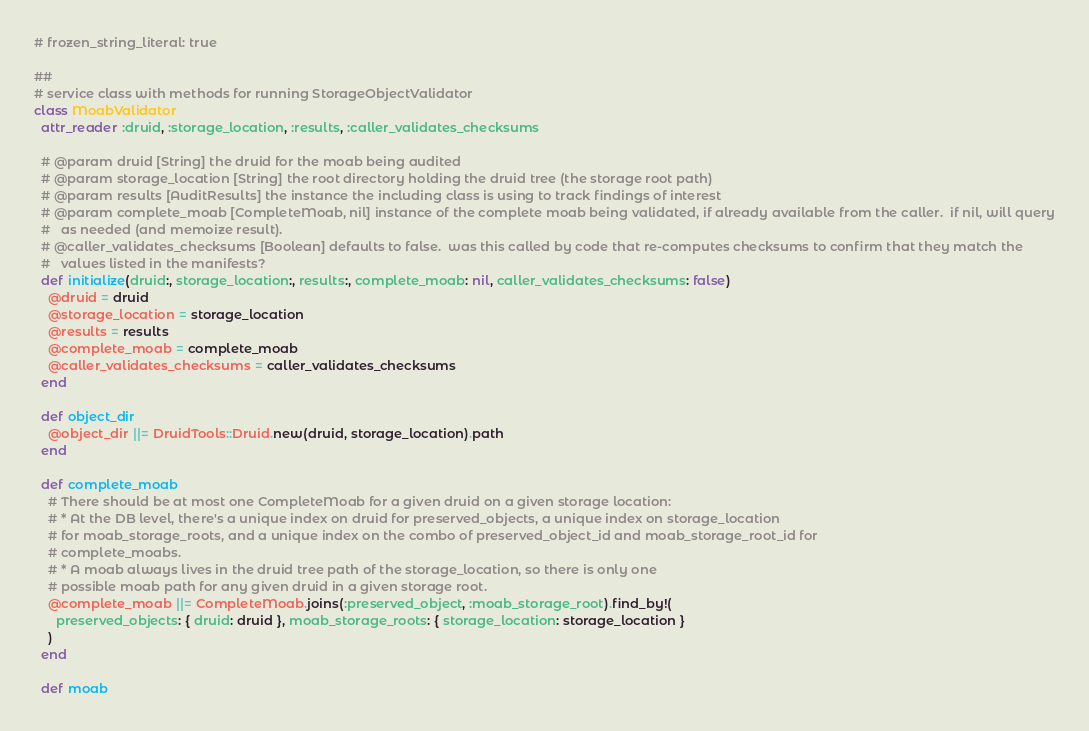<code> <loc_0><loc_0><loc_500><loc_500><_Ruby_># frozen_string_literal: true

##
# service class with methods for running StorageObjectValidator
class MoabValidator
  attr_reader :druid, :storage_location, :results, :caller_validates_checksums

  # @param druid [String] the druid for the moab being audited
  # @param storage_location [String] the root directory holding the druid tree (the storage root path)
  # @param results [AuditResults] the instance the including class is using to track findings of interest
  # @param complete_moab [CompleteMoab, nil] instance of the complete moab being validated, if already available from the caller.  if nil, will query
  #   as needed (and memoize result).
  # @caller_validates_checksums [Boolean] defaults to false.  was this called by code that re-computes checksums to confirm that they match the
  #   values listed in the manifests?
  def initialize(druid:, storage_location:, results:, complete_moab: nil, caller_validates_checksums: false)
    @druid = druid
    @storage_location = storage_location
    @results = results
    @complete_moab = complete_moab
    @caller_validates_checksums = caller_validates_checksums
  end

  def object_dir
    @object_dir ||= DruidTools::Druid.new(druid, storage_location).path
  end

  def complete_moab
    # There should be at most one CompleteMoab for a given druid on a given storage location:
    # * At the DB level, there's a unique index on druid for preserved_objects, a unique index on storage_location
    # for moab_storage_roots, and a unique index on the combo of preserved_object_id and moab_storage_root_id for
    # complete_moabs.
    # * A moab always lives in the druid tree path of the storage_location, so there is only one
    # possible moab path for any given druid in a given storage root.
    @complete_moab ||= CompleteMoab.joins(:preserved_object, :moab_storage_root).find_by!(
      preserved_objects: { druid: druid }, moab_storage_roots: { storage_location: storage_location }
    )
  end

  def moab</code> 